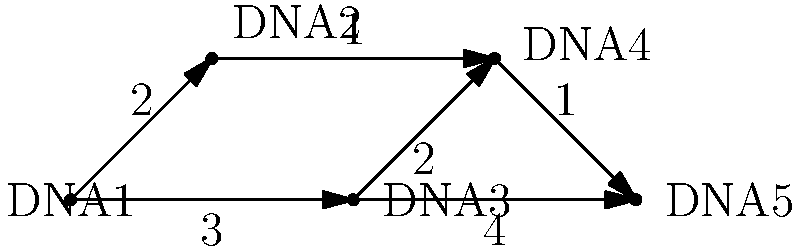In a DNA connection network, each node represents a DNA sample, and the edges represent genetic similarities with associated weights. The weight of an edge indicates the strength of the genetic connection (lower weight means stronger connection). What is the shortest path from DNA1 to DNA5, and what is its total weight? To find the shortest path from DNA1 to DNA5, we need to consider all possible paths and their total weights. Let's examine each path step-by-step:

1. Path 1: DNA1 → DNA2 → DNA4 → DNA5
   Total weight = 2 + 1 + 1 = 4

2. Path 2: DNA1 → DNA3 → DNA4 → DNA5
   Total weight = 3 + 2 + 1 = 6

3. Path 3: DNA1 → DNA3 → DNA5
   Total weight = 3 + 4 = 7

The shortest path is the one with the lowest total weight. Among the three possible paths, Path 1 (DNA1 → DNA2 → DNA4 → DNA5) has the lowest total weight of 4.
Answer: DNA1 → DNA2 → DNA4 → DNA5; total weight: 4 